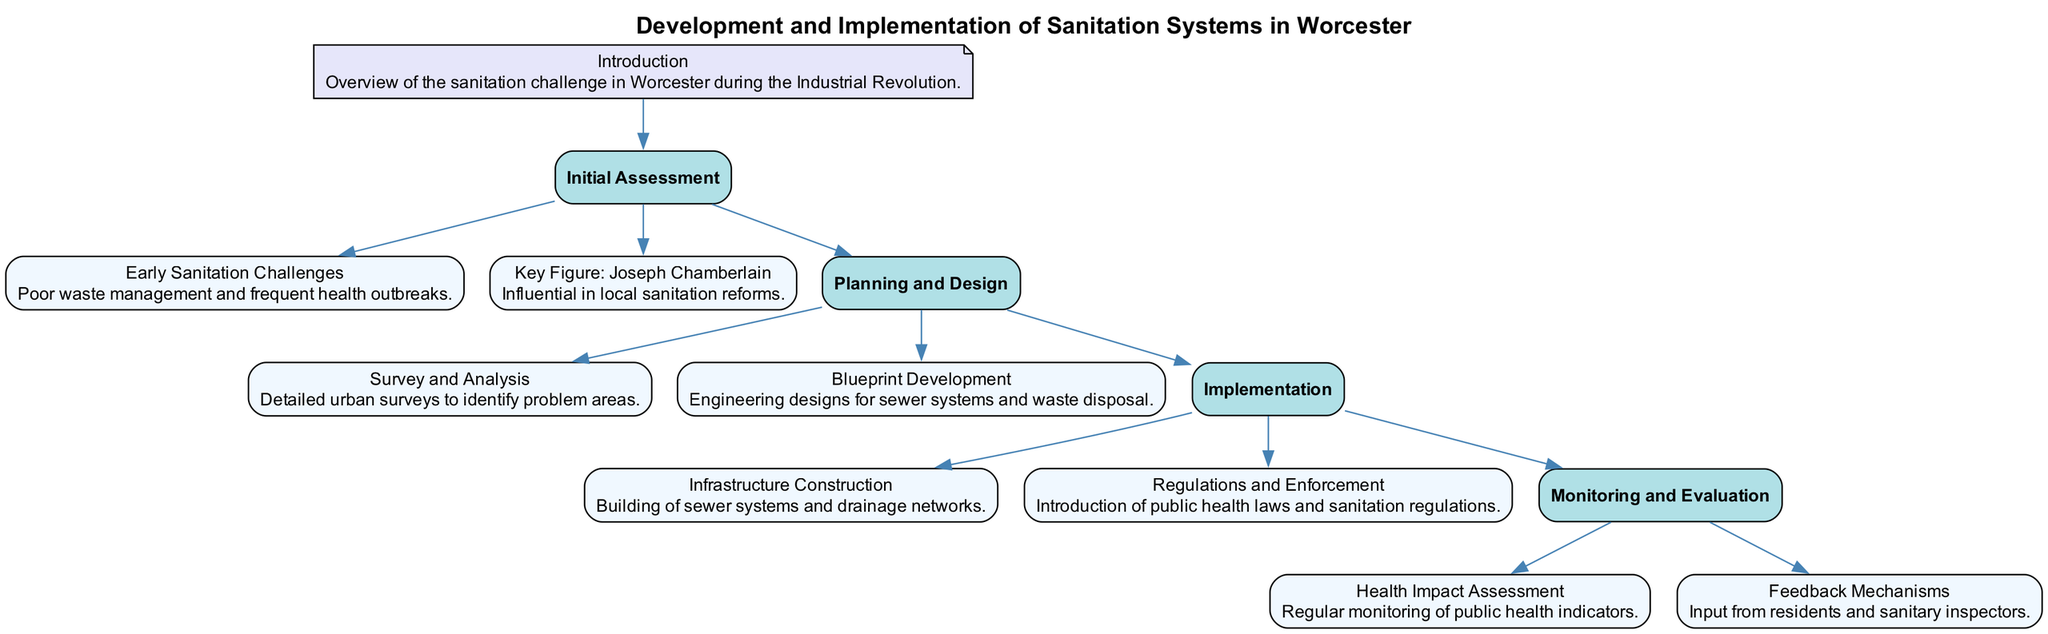What is the title of the clinical pathway? The title of the clinical pathway is located at the top of the diagram. It describes the main focus of the content, which is "Development and Implementation of Sanitation Systems in Worcester."
Answer: Development and Implementation of Sanitation Systems in Worcester How many main stages are there in the diagram? By counting the major sections labeled as stages in the diagram, we identify four key stages: Initial Assessment, Planning and Design, Implementation, and Monitoring and Evaluation.
Answer: 4 Who is the key figure mentioned in the initial assessment? In the "Initial Assessment" stage, one of the components specifically mentions Joseph Chamberlain as the key figure influential in local sanitation reforms.
Answer: Joseph Chamberlain What is the first step in the Implementation stage? The first component listed under the "Implementation" stage is "Infrastructure Construction," which outlines the initial actions taken to improve sanitation systems.
Answer: Infrastructure Construction What type of assessment is conducted in the Monitoring and Evaluation stage? The "Monitoring and Evaluation" stage includes a health-related component titled "Health Impact Assessment," indicating the focus of analysis within this stage.
Answer: Health Impact Assessment Name one of the components in the Planning and Design stage. In the "Planning and Design" stage, two components are listed. One of them is "Blueprint Development," which details a specific aspect of the planning process.
Answer: Blueprint Development What is the focus of the Feedback Mechanisms in the Monitoring and Evaluation stage? The "Feedback Mechanisms" component suggests that the focus is on gathering input from two specific groups: residents and sanitary inspectors, indicating a collaborative approach to sanitation evaluation.
Answer: Input from residents and sanitary inspectors How do the stages relate to each other in the diagram? The diagram demonstrates a clear flow from one stage to the next, starting with the "Initial Assessment," followed by "Planning and Design," "Implementation," and concluding with "Monitoring and Evaluation," indicative of a sequential process.
Answer: Sequential process What is highlighted in the survey and analysis component? The component "Survey and Analysis" in the "Planning and Design" stage emphasizes the importance of conducting detailed urban surveys to identify specific problem areas related to sanitation.
Answer: Detailed urban surveys What mechanisms are introduced in the regulations and enforcement component? The "Regulations and Enforcement" component specifically mentions the introduction of public health laws that guide sanitation practices, signifying a regulatory approach to the management of sanitation.
Answer: Public health laws and sanitation regulations 